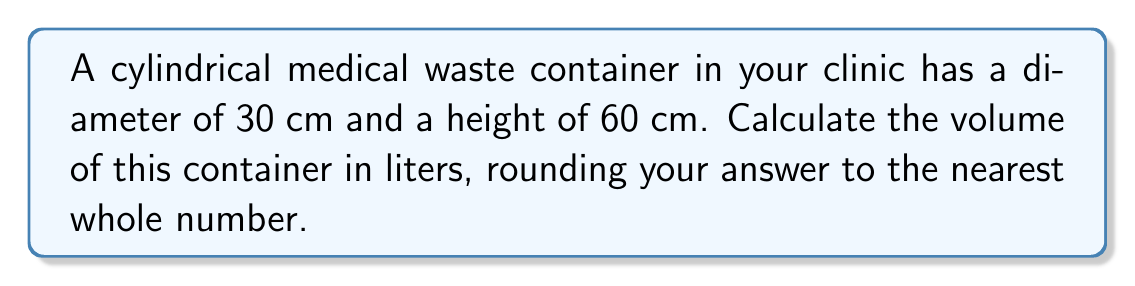Can you answer this question? To determine the volume of a cylindrical container, we use the formula:

$$V = \pi r^2 h$$

Where:
$V$ = volume
$r$ = radius of the base
$h$ = height of the cylinder

Steps:
1. Calculate the radius:
   Diameter = 30 cm, so radius = 30 cm ÷ 2 = 15 cm

2. Apply the formula:
   $$V = \pi (15 \text{ cm})^2 (60 \text{ cm})$$

3. Calculate:
   $$V = \pi (225 \text{ cm}^2) (60 \text{ cm})$$
   $$V = 42,411.50 \text{ cm}^3$$

4. Convert cm³ to liters:
   1 liter = 1000 cm³
   $$42,411.50 \text{ cm}^3 \div 1000 = 42.41 \text{ liters}$$

5. Round to the nearest whole number:
   42.41 liters ≈ 42 liters
Answer: 42 liters 